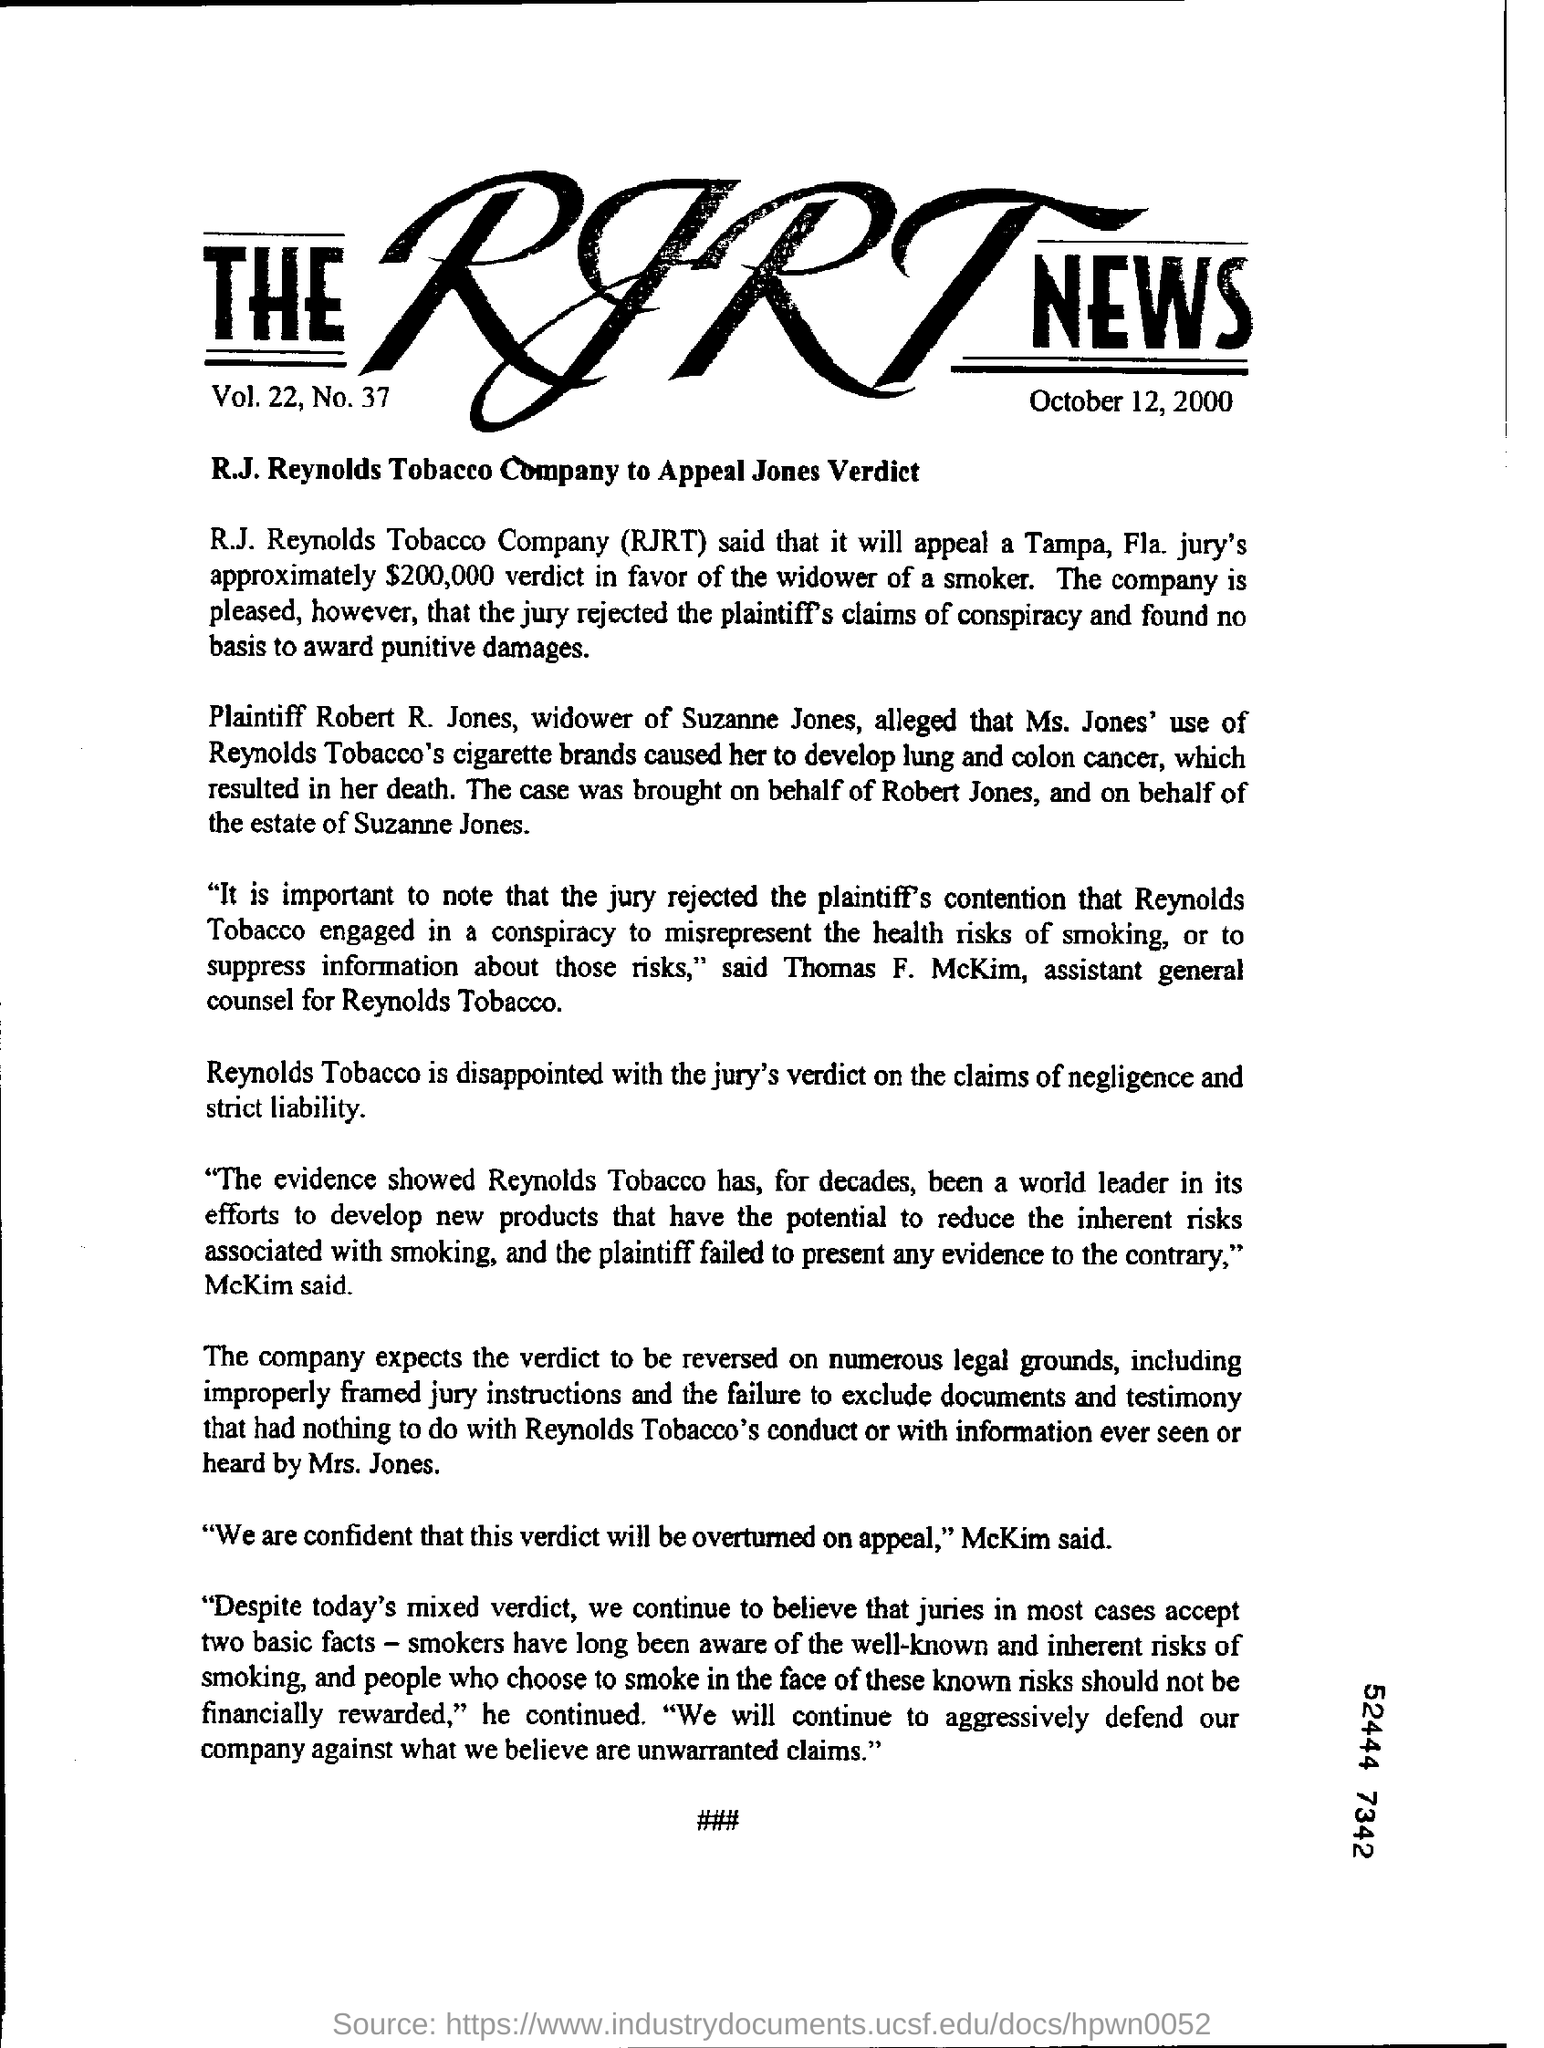What is the heading of the document?
Your answer should be very brief. The RJRT News. What is the date given under the heading?
Keep it short and to the point. October 12, 2000. What is the expansion of RJRT?
Make the answer very short. R.J. Reynolds Tobacco. Who is the widower of Suzanne Jones?
Your response must be concise. Robert R. Jones. Ms. Jones' death was due to what disease?
Offer a very short reply. Lung and colon cancer. Who is the "assistant general counsel for Reynolds Tobacco"?
Your answer should be very brief. Thomas F. McKim. 